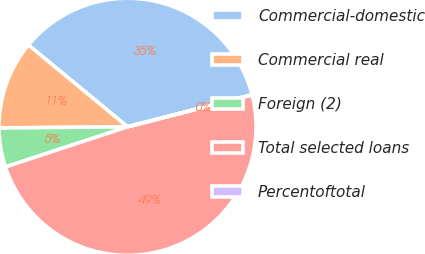Convert chart to OTSL. <chart><loc_0><loc_0><loc_500><loc_500><pie_chart><fcel>Commercial-domestic<fcel>Commercial real<fcel>Foreign (2)<fcel>Total selected loans<fcel>Percentoftotal<nl><fcel>35.01%<fcel>11.13%<fcel>4.91%<fcel>48.93%<fcel>0.02%<nl></chart> 